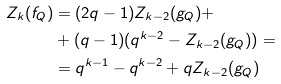Convert formula to latex. <formula><loc_0><loc_0><loc_500><loc_500>Z _ { k } ( f _ { Q } ) & = ( 2 q - 1 ) Z _ { k - 2 } ( g _ { Q } ) + \\ & + ( q - 1 ) ( q ^ { k - 2 } - Z _ { k - 2 } ( g _ { Q } ) ) = \\ & = q ^ { k - 1 } - q ^ { k - 2 } + q Z _ { k - 2 } ( g _ { Q } )</formula> 